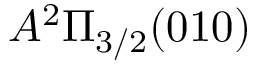<formula> <loc_0><loc_0><loc_500><loc_500>A ^ { 2 } \Pi _ { 3 / 2 } ( 0 1 0 )</formula> 